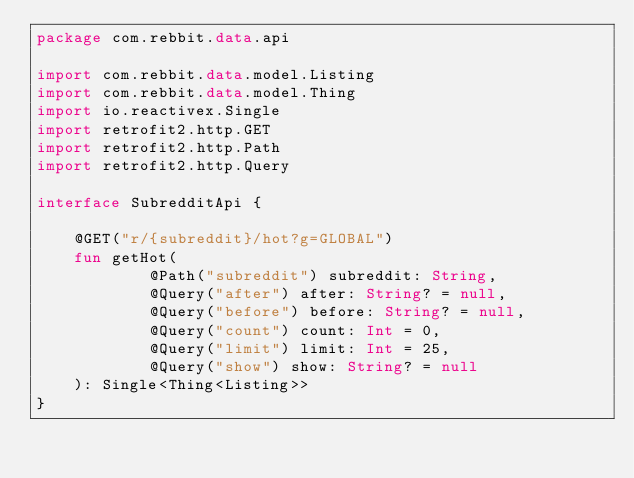<code> <loc_0><loc_0><loc_500><loc_500><_Kotlin_>package com.rebbit.data.api

import com.rebbit.data.model.Listing
import com.rebbit.data.model.Thing
import io.reactivex.Single
import retrofit2.http.GET
import retrofit2.http.Path
import retrofit2.http.Query

interface SubredditApi {

    @GET("r/{subreddit}/hot?g=GLOBAL")
    fun getHot(
            @Path("subreddit") subreddit: String,
            @Query("after") after: String? = null,
            @Query("before") before: String? = null,
            @Query("count") count: Int = 0,
            @Query("limit") limit: Int = 25,
            @Query("show") show: String? = null
    ): Single<Thing<Listing>>
}</code> 